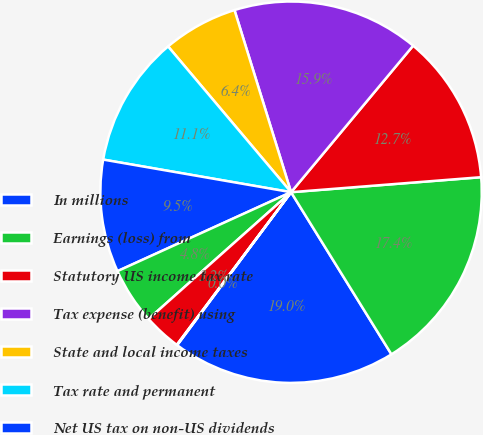Convert chart to OTSL. <chart><loc_0><loc_0><loc_500><loc_500><pie_chart><fcel>In millions<fcel>Earnings (loss) from<fcel>Statutory US income tax rate<fcel>Tax expense (benefit) using<fcel>State and local income taxes<fcel>Tax rate and permanent<fcel>Net US tax on non-US dividends<fcel>Tax benefit on manufacturing<fcel>Non-deductible business<fcel>Retirement plan dividends<nl><fcel>19.01%<fcel>17.43%<fcel>12.69%<fcel>15.85%<fcel>6.36%<fcel>11.11%<fcel>9.53%<fcel>4.78%<fcel>3.2%<fcel>0.04%<nl></chart> 